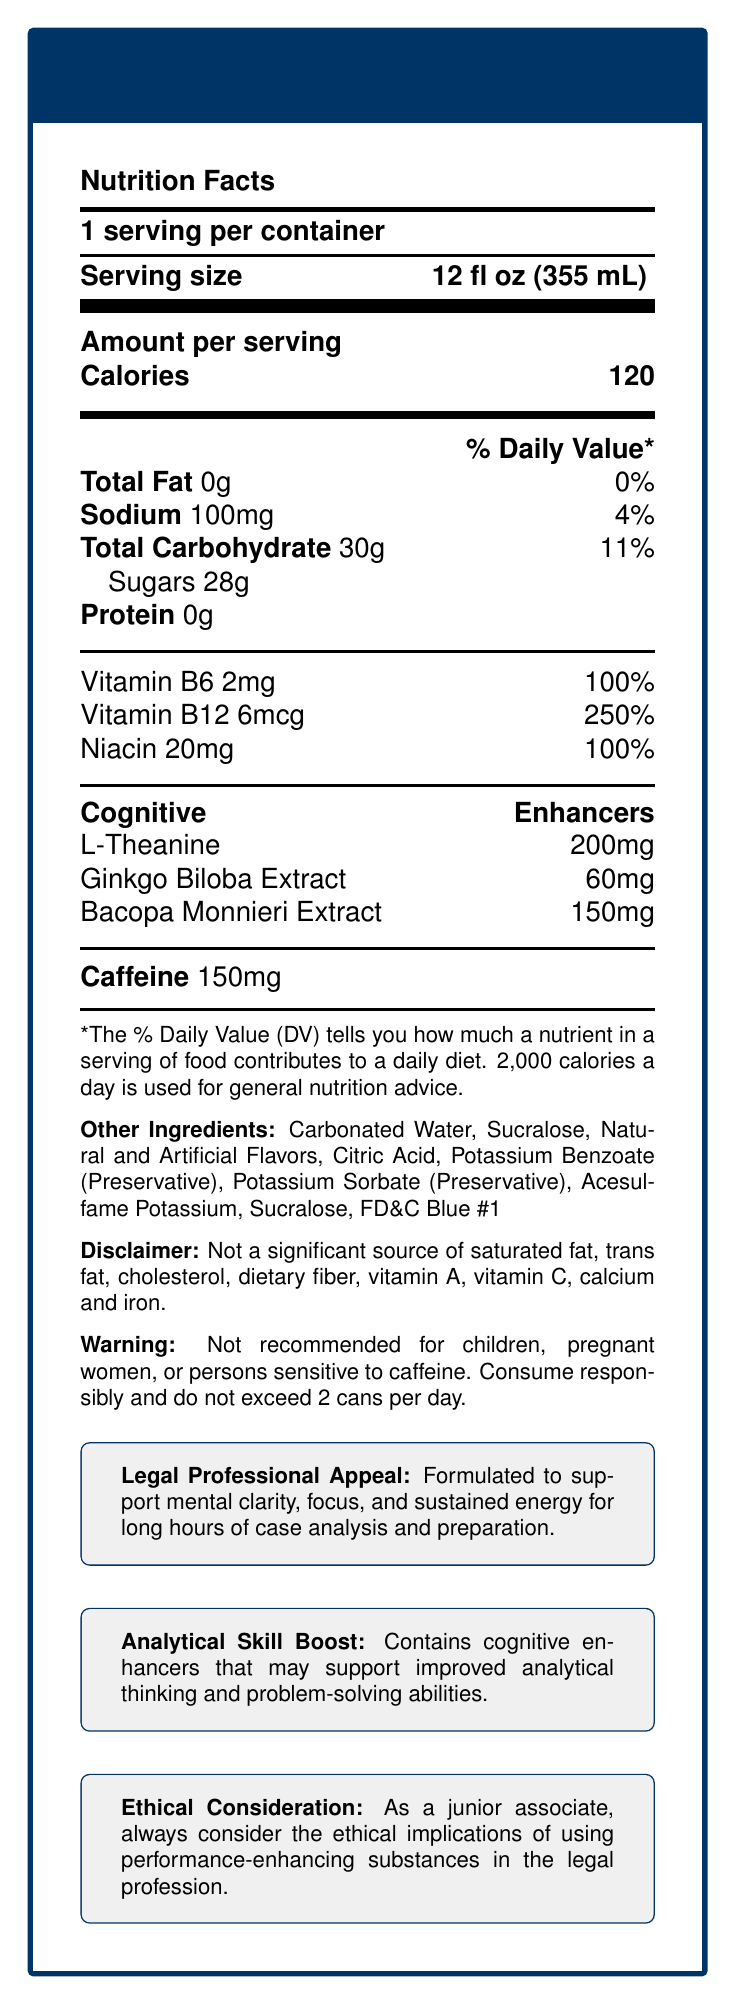what is the serving size for one container? The serving size is clearly mentioned at the top of the Nutrition Facts section: "Serving size 12 fl oz (355 mL)".
Answer: 12 fl oz (355 mL) how many calories are there per serving? The document states the number of calories per serving directly under the "Amount per serving" section as "Calories 120".
Answer: 120 how much caffeine does one serving contain? The amount of caffeine per serving is listed in a separate section labeled "Caffeine" and states "150mg".
Answer: 150mg what percentage of the daily value for Vitamin B12 does one serving provide? Beneath the vitamins and minerals section, the document specifies "Vitamin B12 6mcg 250%".
Answer: 250% what are the cognitive enhancers included in the drink? The document lists the cognitive enhancers under the section labeled "Cognitive Enhancers" with their respective amounts.
Answer: L-Theanine, Ginkgo Biloba Extract, Bacopa Monnieri Extract which of the following ingredients is NOT listed in the "other ingredients" section? A. Carbonated Water B. Maltodextrin C. Acesulfame Potassium The document lists "Carbonated Water" and "Acesulfame Potassium", but not "Maltodextrin".
Answer: B what is the warning given in the document? A. Not recommended for children B. Not recommended for people with heart problems C. Illegal for use in sports D. Causes drowsiness The warning states: "Not recommended for children, pregnant women, or persons sensitive to caffeine. Consume responsibly and do not exceed 2 cans per day."
Answer: A does the energy drink contain iron? According to the disclaimer, this product is "Not a significant source of saturated fat, trans fat, cholesterol, dietary fiber, vitamin A, vitamin C, calcium and iron."
Answer: No are the vitamins in the drink significant sources of nutritional value? The percentage daily values of the vitamins listed (Vitamin B6, Vitamin B12, Niacin) range from 100% to 250%, indicating they are significant sources.
Answer: Yes summarize the main idea of the document. The document provides a detailed breakdown of the nutritional content and cognitive enhancers in LegalBoost Energy, targeting legal professionals and emphasizing its benefits for mental performance and energy levels. It also includes warnings and ethical considerations for use.
Answer: LegalBoost Energy is an energy drink formulated to support mental clarity, focus, and sustained energy for legal professionals, with significant amounts of caffeine, vitamins, and cognitive enhancers while having a low amount of fat and protein. does the document specify the exact amount of citric acid used? The "Other Ingredients" section lists "Citric Acid," but does not specify the exact amount used in the formulation.
Answer: Not enough information 